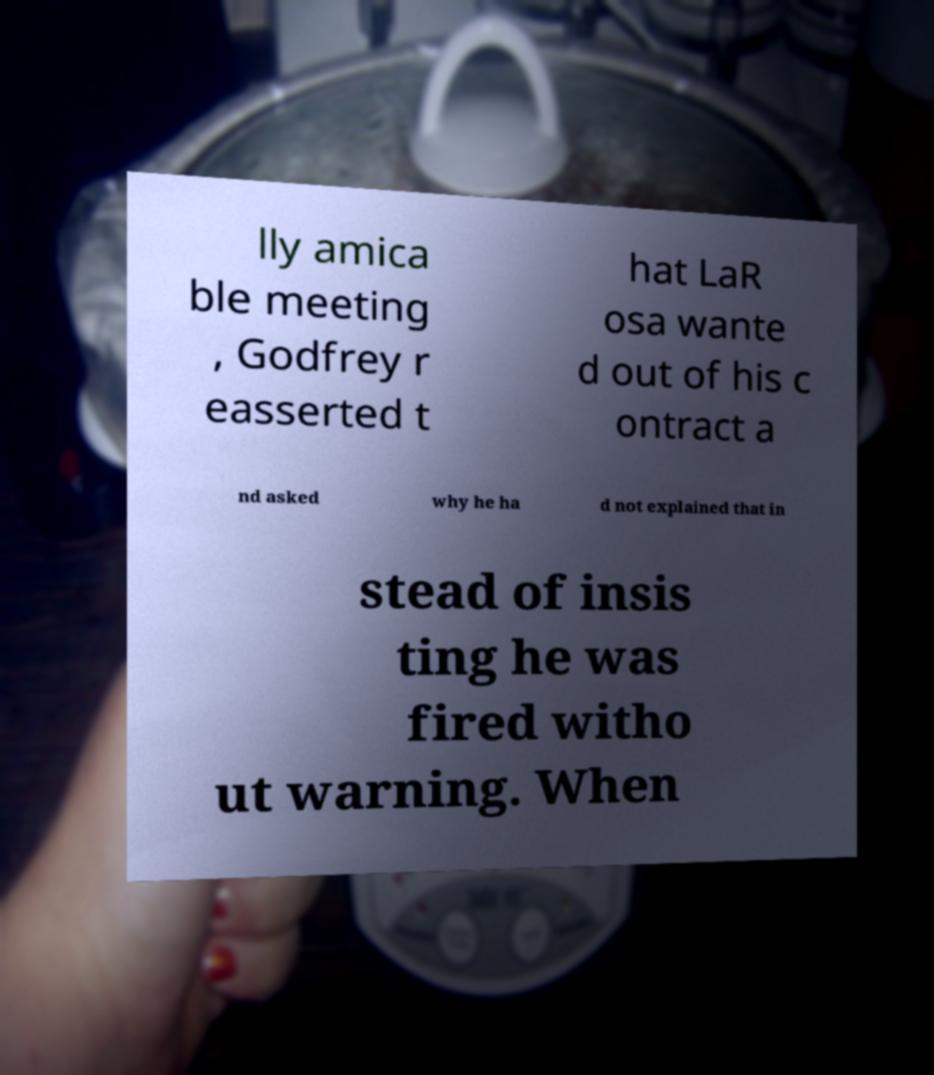Please identify and transcribe the text found in this image. lly amica ble meeting , Godfrey r easserted t hat LaR osa wante d out of his c ontract a nd asked why he ha d not explained that in stead of insis ting he was fired witho ut warning. When 